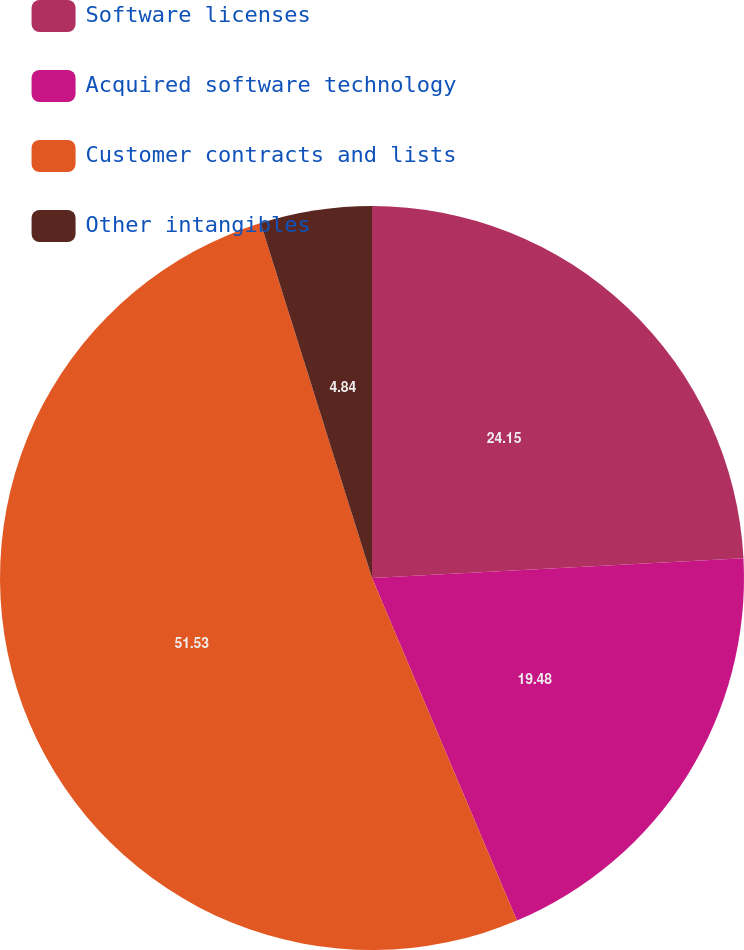Convert chart to OTSL. <chart><loc_0><loc_0><loc_500><loc_500><pie_chart><fcel>Software licenses<fcel>Acquired software technology<fcel>Customer contracts and lists<fcel>Other intangibles<nl><fcel>24.15%<fcel>19.48%<fcel>51.53%<fcel>4.84%<nl></chart> 